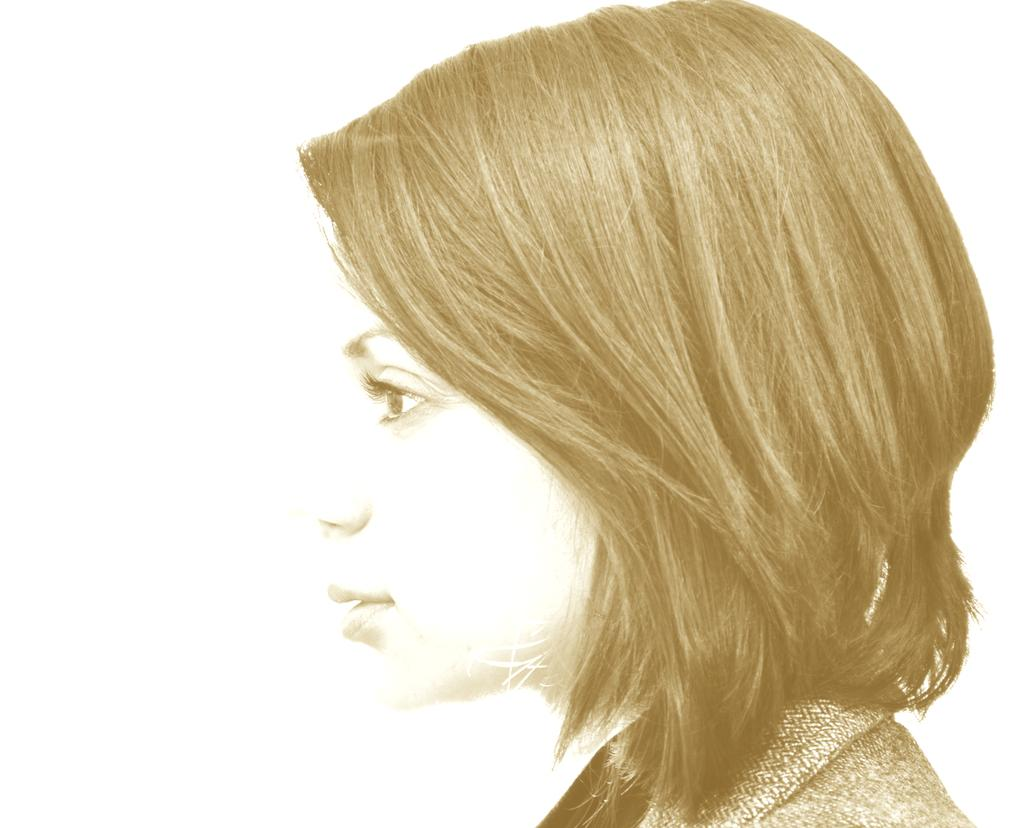Who is present in the image? There is a woman in the image. What can be seen in the background of the image? The background of the image is white. What type of agreement is being signed by the woman in the image? There is no indication of a signed agreement or any signing activity in the image. 